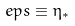<formula> <loc_0><loc_0><loc_500><loc_500>\ e p s \equiv \eta _ { * }</formula> 